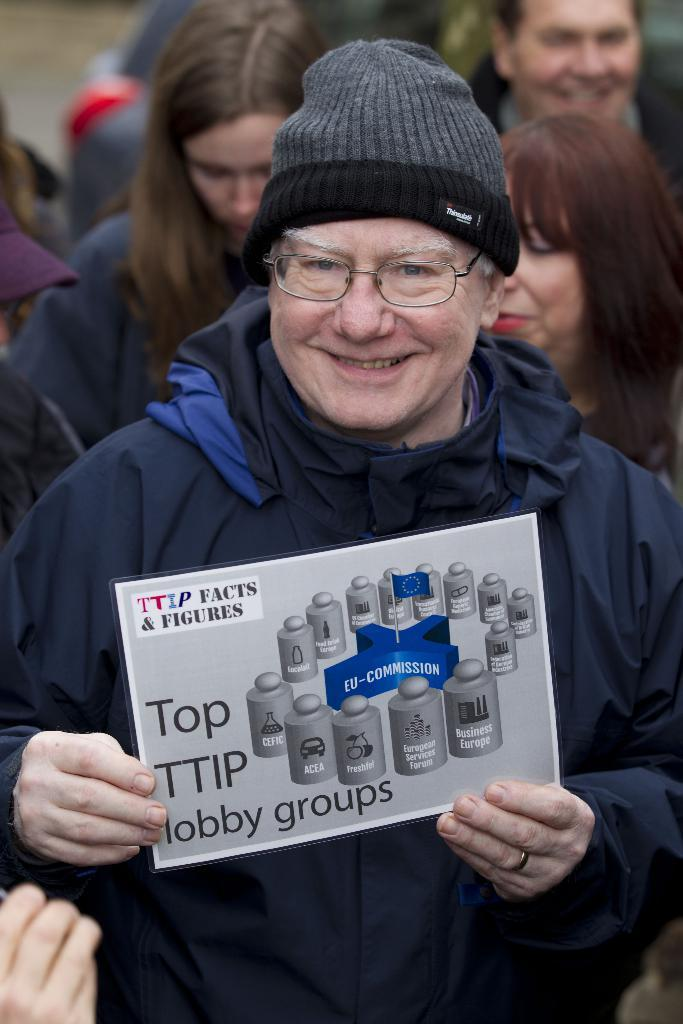What is the main subject of the image? The main subject of the image is a person posing for a picture. What is the person holding in the image? The person is holding a poster. What can be seen on the poster? The poster contains text and logos. Who else is present in the image? There is a group of people standing behind the person. What type of berry is being traded in the image? There is no mention of berries or trading in the image; it features a person holding a poster with text and logos. What sign is the person holding in the image? The person is not holding a sign; they are holding a poster with text and logos. 